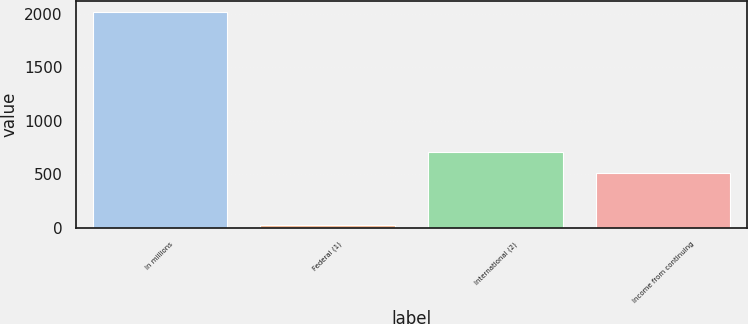Convert chart to OTSL. <chart><loc_0><loc_0><loc_500><loc_500><bar_chart><fcel>In millions<fcel>Federal (1)<fcel>International (2)<fcel>Income from continuing<nl><fcel>2015<fcel>21.8<fcel>711.82<fcel>512.5<nl></chart> 